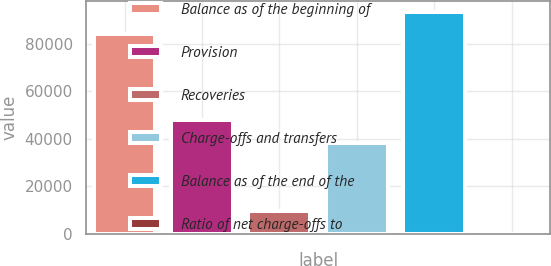Convert chart. <chart><loc_0><loc_0><loc_500><loc_500><bar_chart><fcel>Balance as of the beginning of<fcel>Provision<fcel>Recoveries<fcel>Charge-offs and transfers<fcel>Balance as of the end of the<fcel>Ratio of net charge-offs to<nl><fcel>84073<fcel>47750<fcel>9357.96<fcel>38376<fcel>93535<fcel>4.95<nl></chart> 